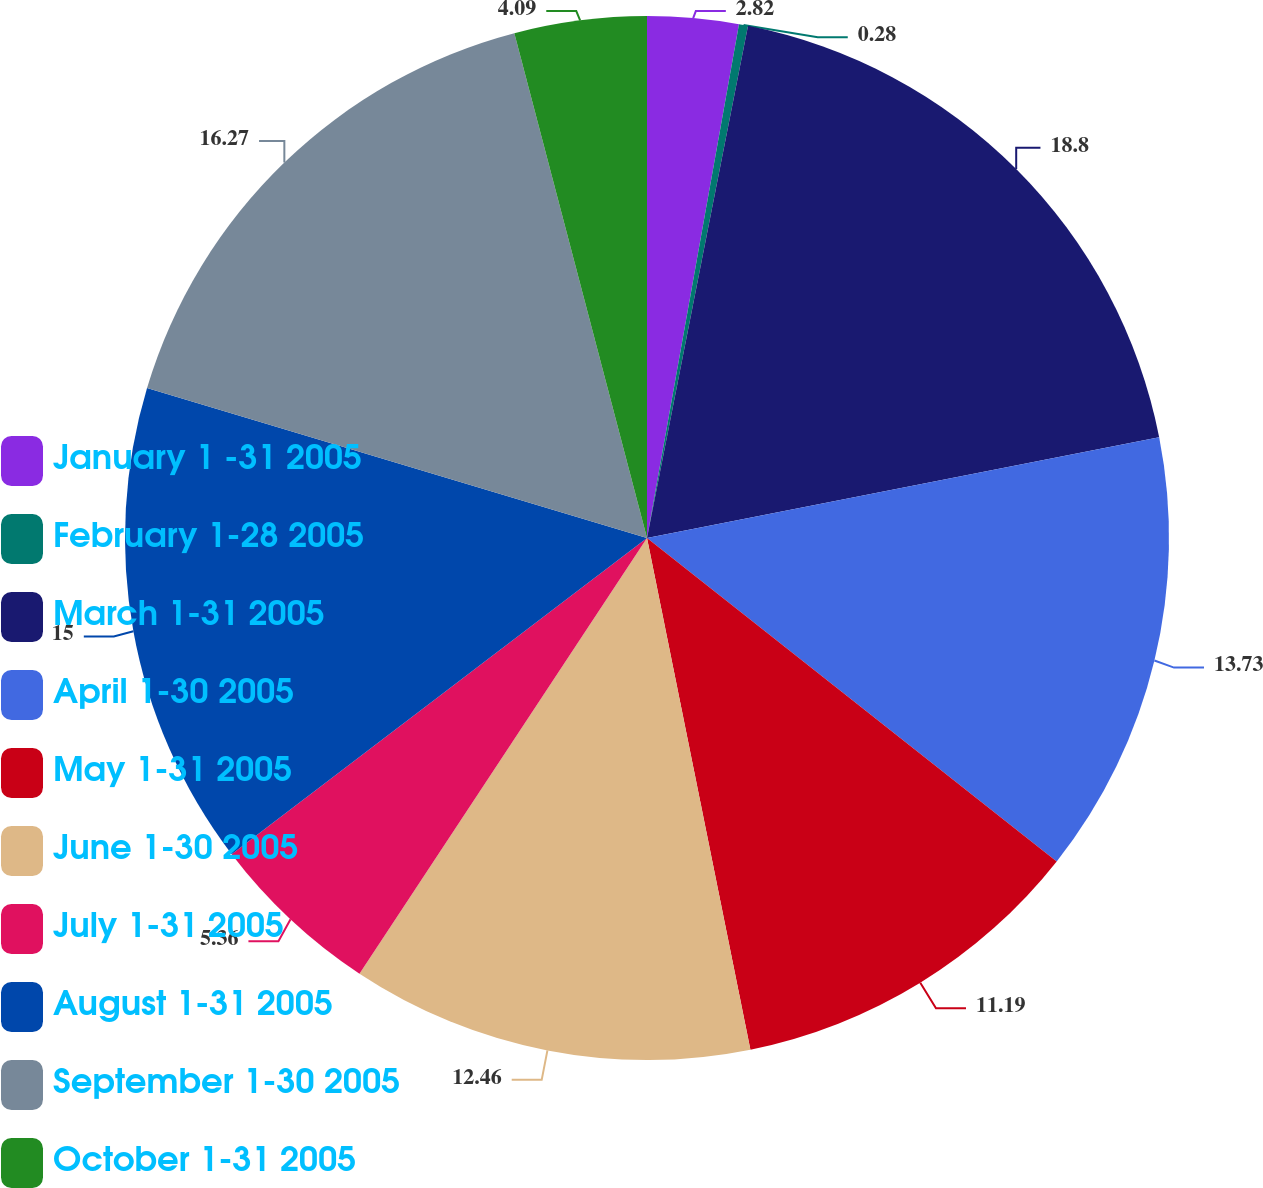Convert chart. <chart><loc_0><loc_0><loc_500><loc_500><pie_chart><fcel>January 1 -31 2005<fcel>February 1-28 2005<fcel>March 1-31 2005<fcel>April 1-30 2005<fcel>May 1-31 2005<fcel>June 1-30 2005<fcel>July 1-31 2005<fcel>August 1-31 2005<fcel>September 1-30 2005<fcel>October 1-31 2005<nl><fcel>2.82%<fcel>0.28%<fcel>18.81%<fcel>13.73%<fcel>11.19%<fcel>12.46%<fcel>5.36%<fcel>15.0%<fcel>16.27%<fcel>4.09%<nl></chart> 